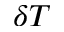Convert formula to latex. <formula><loc_0><loc_0><loc_500><loc_500>\delta T</formula> 